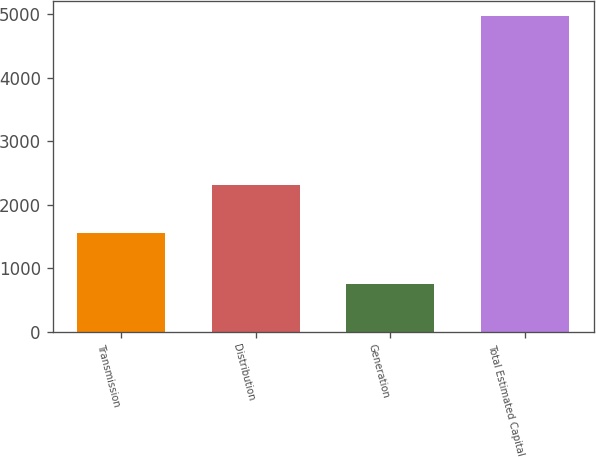<chart> <loc_0><loc_0><loc_500><loc_500><bar_chart><fcel>Transmission<fcel>Distribution<fcel>Generation<fcel>Total Estimated Capital<nl><fcel>1547<fcel>2304<fcel>743<fcel>4967<nl></chart> 